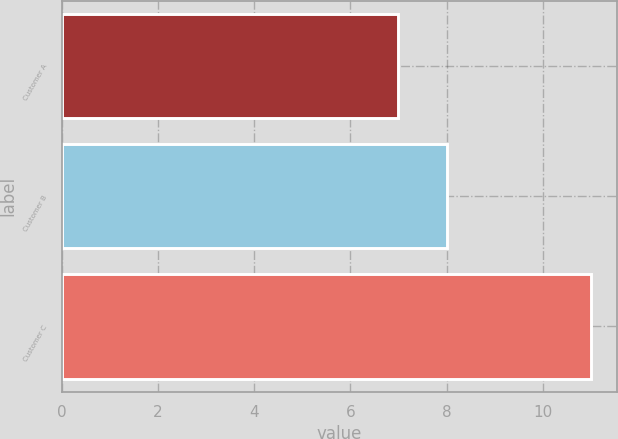Convert chart to OTSL. <chart><loc_0><loc_0><loc_500><loc_500><bar_chart><fcel>Customer A<fcel>Customer B<fcel>Customer C<nl><fcel>7<fcel>8<fcel>11<nl></chart> 